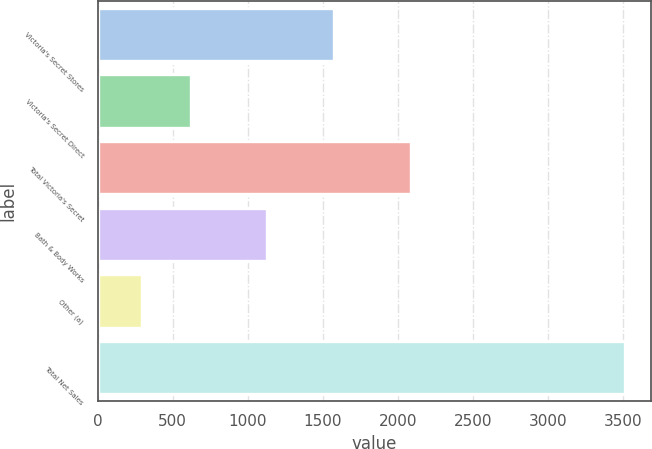Convert chart to OTSL. <chart><loc_0><loc_0><loc_500><loc_500><bar_chart><fcel>Victoria's Secret Stores<fcel>Victoria's Secret Direct<fcel>Total Victoria's Secret<fcel>Bath & Body Works<fcel>Other (a)<fcel>Total Net Sales<nl><fcel>1572<fcel>619.7<fcel>2090<fcel>1127<fcel>298<fcel>3515<nl></chart> 